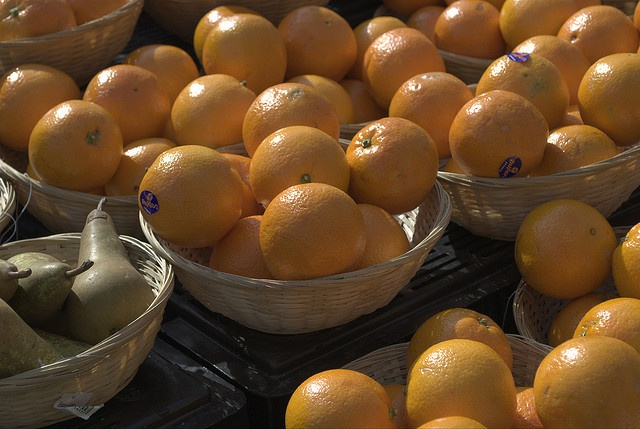Describe the objects in this image and their specific colors. I can see orange in salmon, maroon, brown, and black tones, bowl in salmon, maroon, brown, and black tones, orange in salmon, olive, maroon, and orange tones, orange in salmon, maroon, brown, and tan tones, and bowl in salmon, black, and gray tones in this image. 